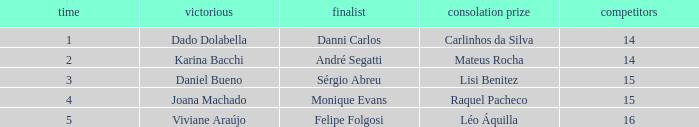In what season did Raquel Pacheco finish in third place? 4.0. 